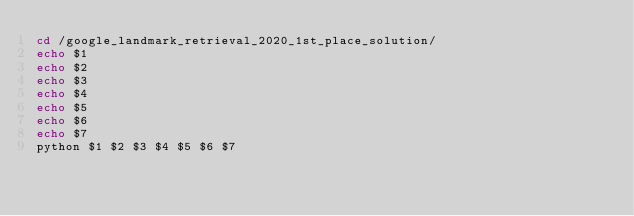<code> <loc_0><loc_0><loc_500><loc_500><_Bash_>cd /google_landmark_retrieval_2020_1st_place_solution/
echo $1
echo $2
echo $3
echo $4
echo $5
echo $6
echo $7
python $1 $2 $3 $4 $5 $6 $7

</code> 